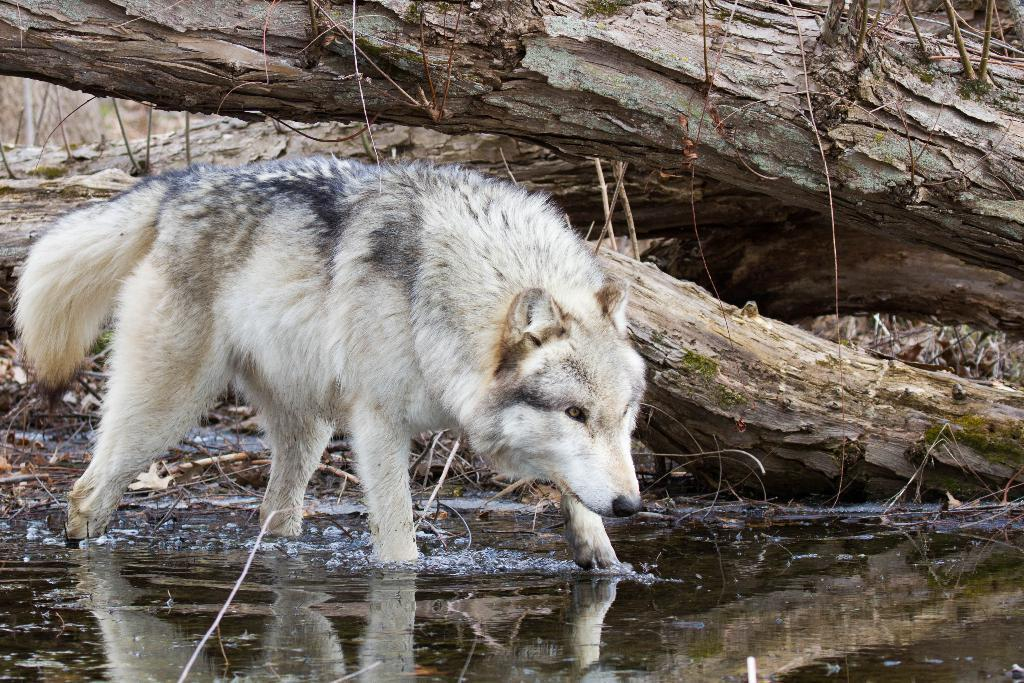What type of animal is in the image? There is a white-colored wolf in the image. Where is the wolf located in the image? The wolf is standing in the water. What can be seen at the bottom of the image? There is water visible at the bottom of the image. What is visible in the background of the image? There are tree trunks in the background of the image. What type of chalk is the wolf using to draw in the water? There is no chalk present in the image, and the wolf is not drawing in the water. 